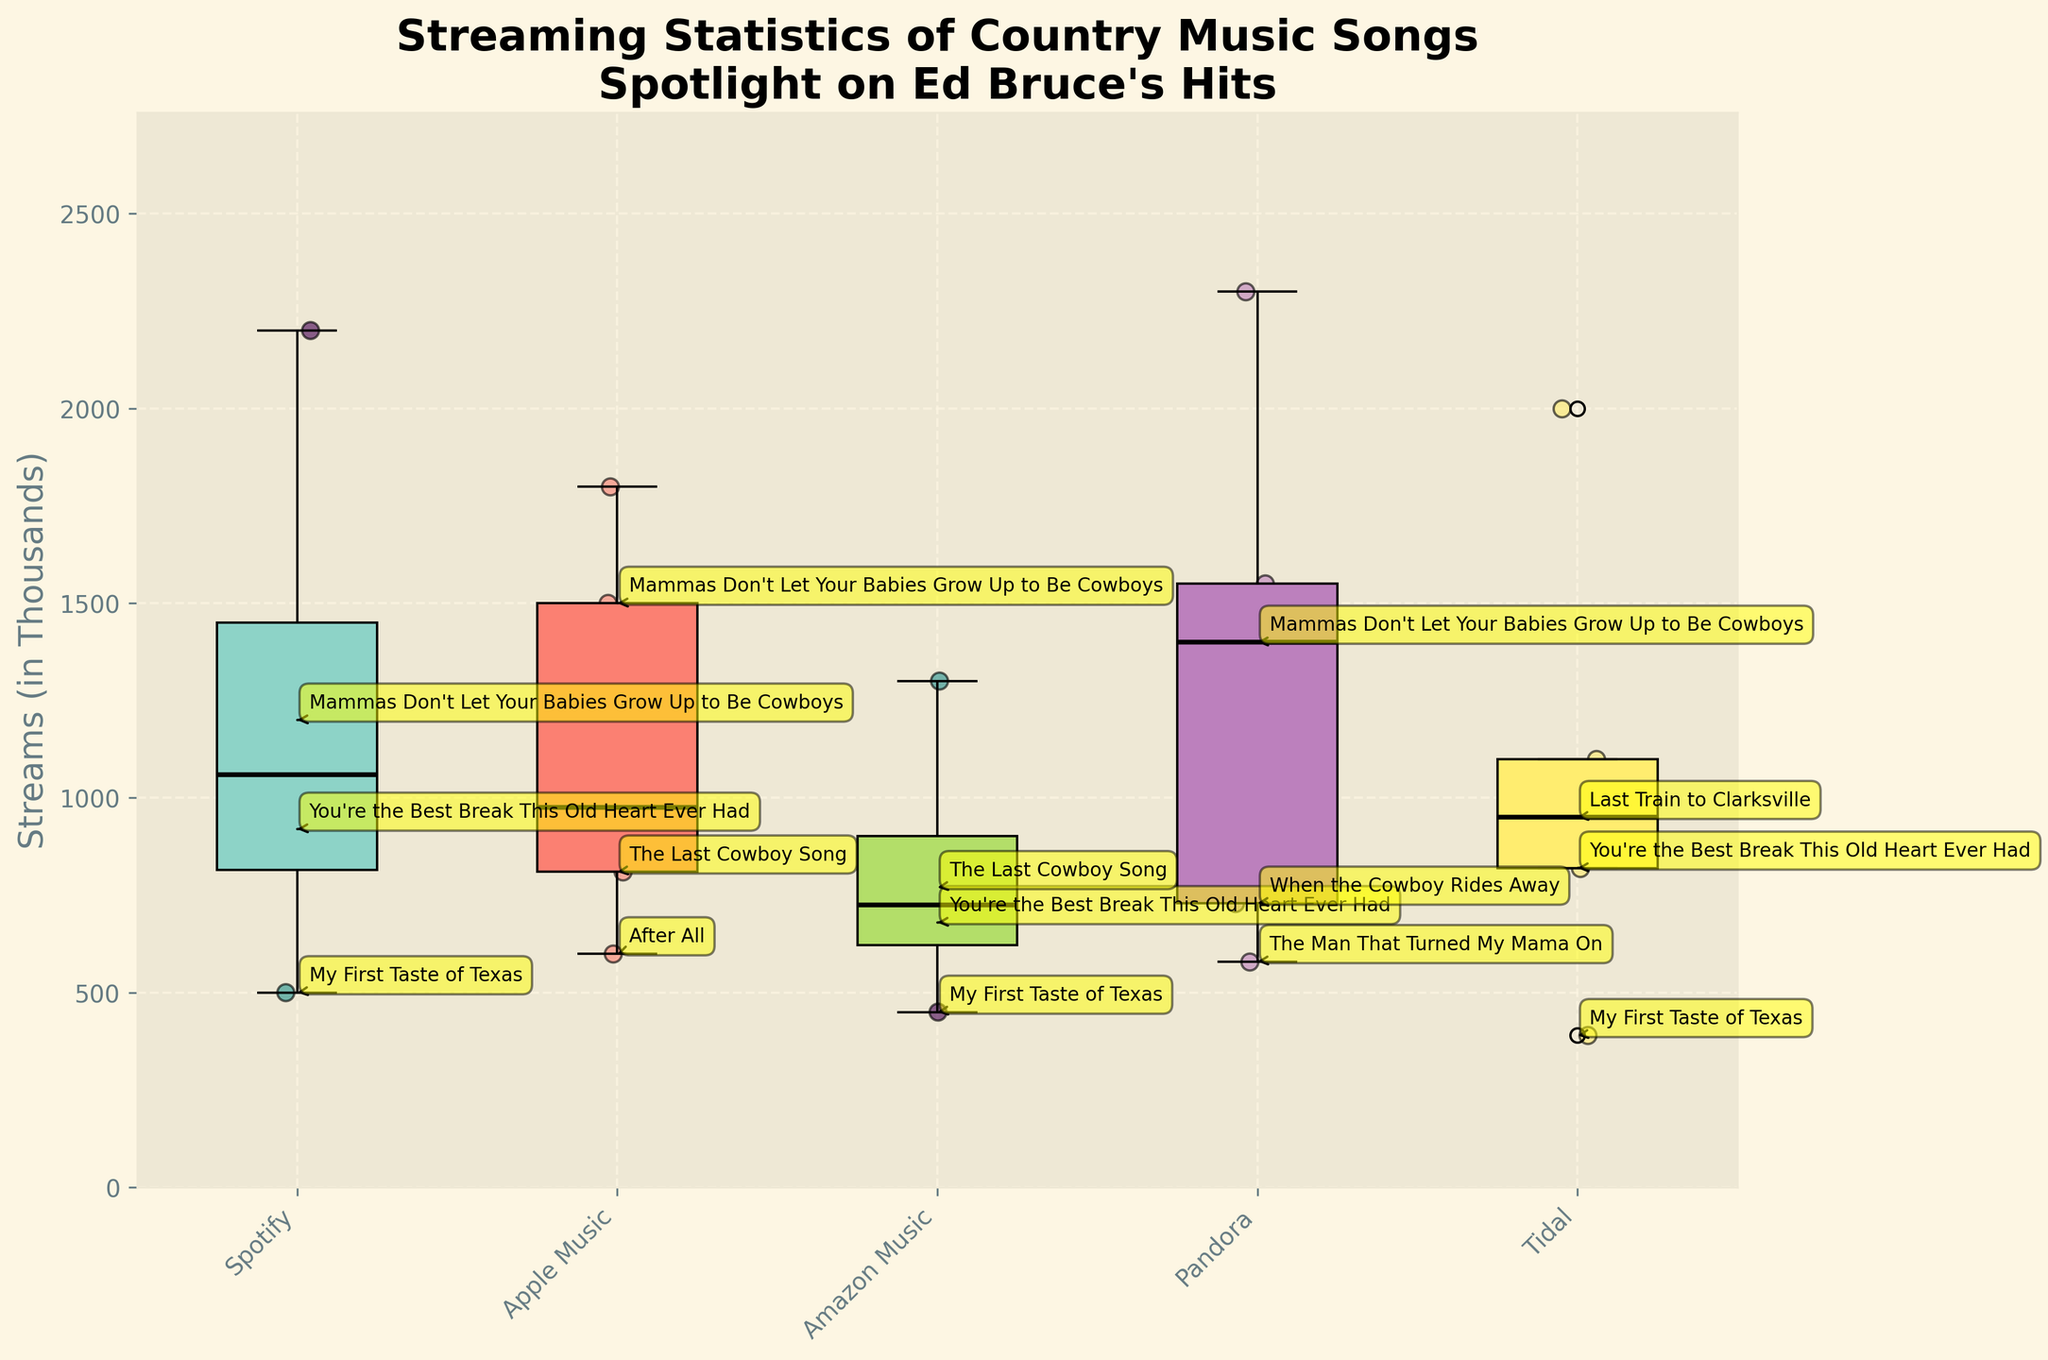What's the title of the figure? The title of the figure is written at the top and describes the main subject of the plot.
Answer: Streaming Statistics of Country Music Songs Spotlight on Ed Bruce’s Hits What does the y-axis represent in the figure? The y-axis represents the number of streams in thousands for the country music songs.
Answer: Streams (in Thousands) Which platform has the song with the highest number of streams? By examining the scatter points, the song with the highest number of streams appears on Pandora. This point is the highest among all scatter points.
Answer: Pandora Which platform has the highest median number of streams? The median of a box plot is shown by the black line within the box. By comparing the black lines across all platforms, it's evident that Pandora has the highest median.
Answer: Pandora What's the median number of streams for songs on Apple Music? The median is indicated by the black line within the box plot for Apple Music.
Answer: 975 How many Ed Bruce songs are featured on Spotify in the plot? The annotations label Ed Bruce’s songs directly on the plot. Count these annotations specific to Spotify.
Answer: 3 Which Ed Bruce song has the highest number of streams on any platform? By looking at the annotated Ed Bruce songs, the one with the highest position on the y-axis across all platforms is visible.
Answer: Mammas Don't Let Your Babies Grow Up to Be Cowboys (1500 on Apple Music) Compare the range of streams for songs on Amazon Music and Tidal. Which has a larger range? The range in a box plot is the difference between the smallest and largest values shown by the ends of the whiskers. By comparing the whiskers of both platforms, Amazon Music's range is larger.
Answer: Amazon Music What is the interquartile range (IQR) for streams on Spotify? The IQR is the difference between the 75th percentile and the 25th percentile, shown by the top and bottom edges of the box. Calculate this by looking at Spotify's box plot.
Answer: Approximated by visual estimation, it's around (1200 - 500) = 700 What's the average number of streams for Ed Bruce’s songs on Pandora? Sum the number of streams for Ed Bruce’s songs on Pandora and divide by the number of those songs. The values are 580, 730, and 1400. Thus, (580 + 730 + 1400) / 3 = 2360 / 3.
Answer: 786.67 